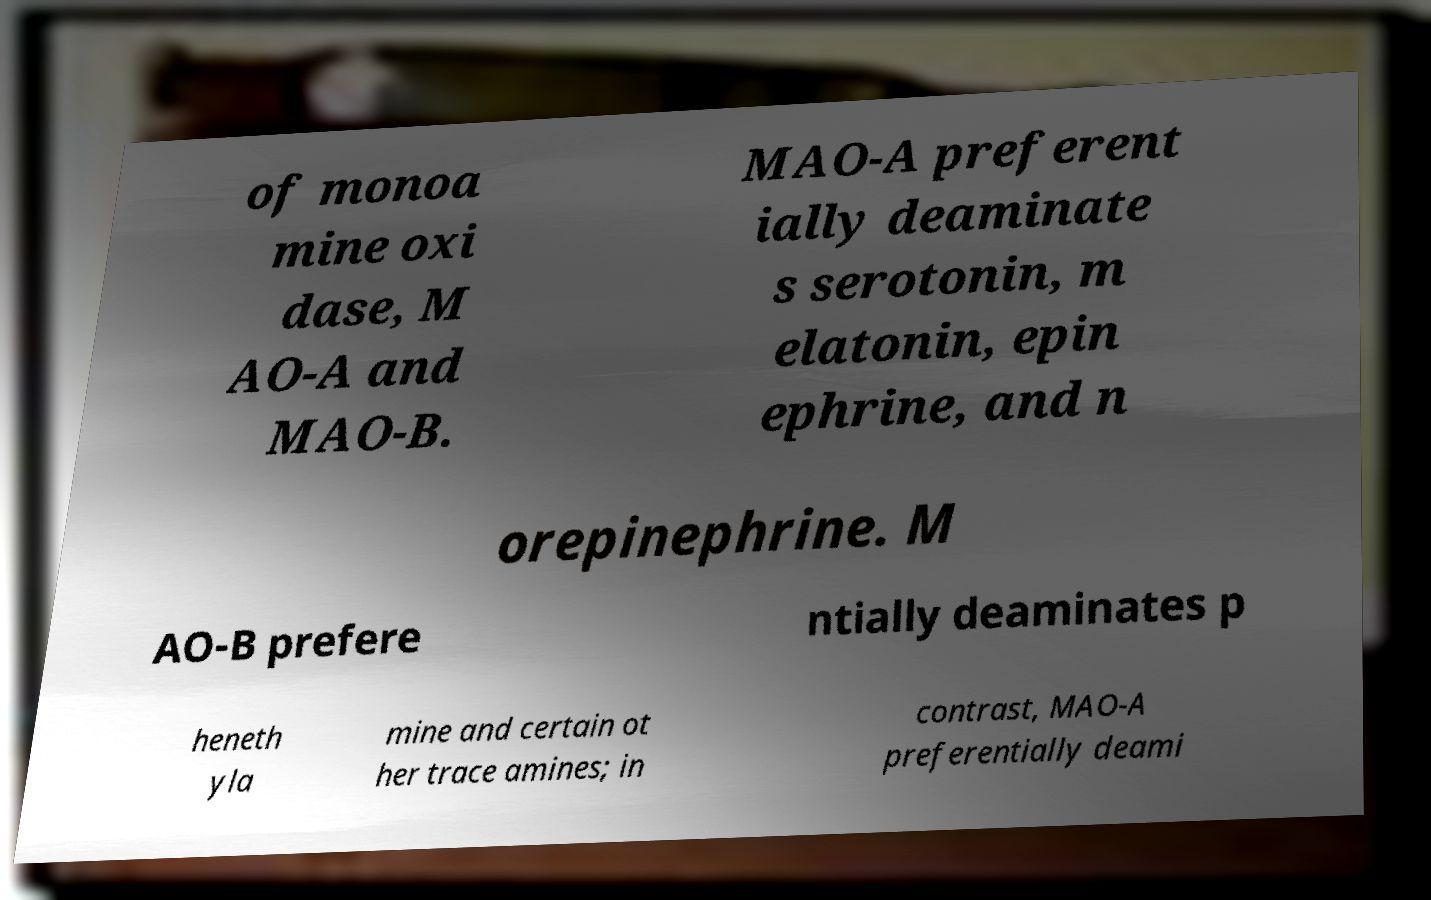Could you assist in decoding the text presented in this image and type it out clearly? of monoa mine oxi dase, M AO-A and MAO-B. MAO-A preferent ially deaminate s serotonin, m elatonin, epin ephrine, and n orepinephrine. M AO-B prefere ntially deaminates p heneth yla mine and certain ot her trace amines; in contrast, MAO-A preferentially deami 